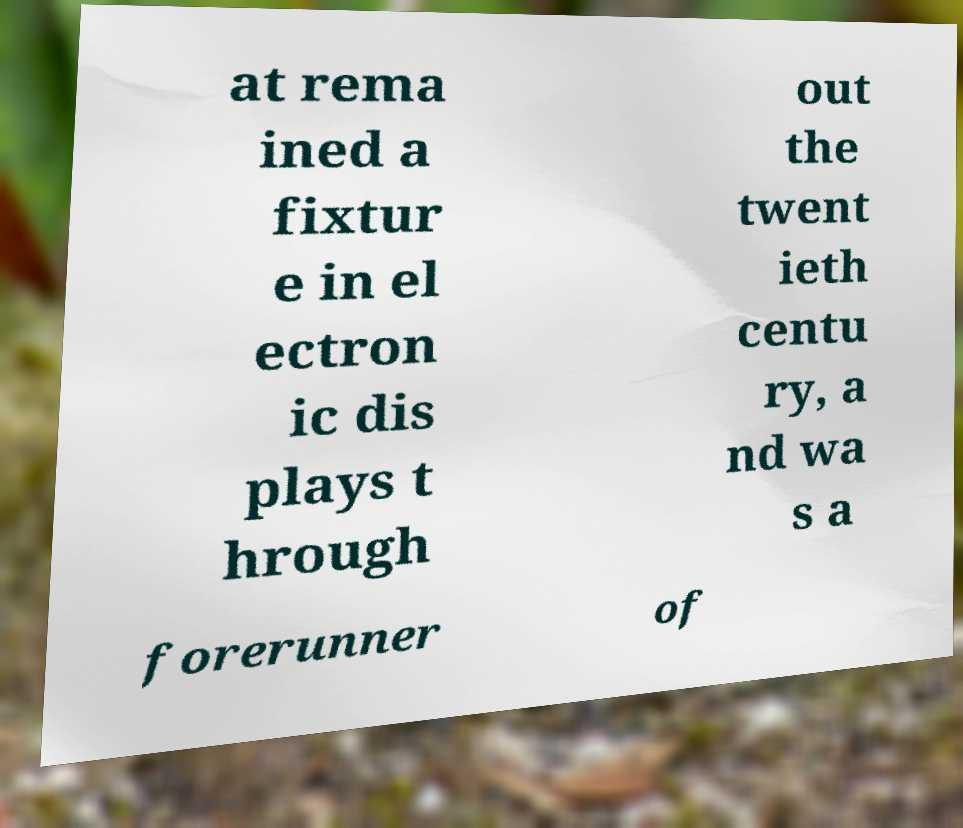For documentation purposes, I need the text within this image transcribed. Could you provide that? at rema ined a fixtur e in el ectron ic dis plays t hrough out the twent ieth centu ry, a nd wa s a forerunner of 